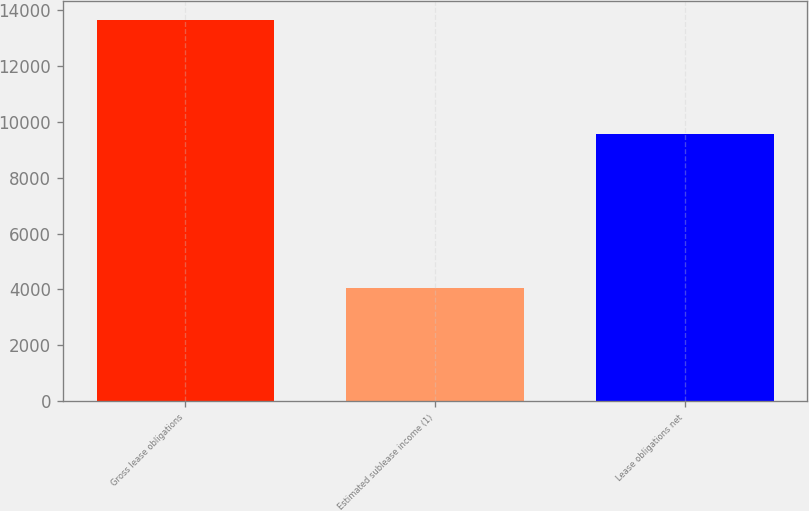Convert chart. <chart><loc_0><loc_0><loc_500><loc_500><bar_chart><fcel>Gross lease obligations<fcel>Estimated sublease income (1)<fcel>Lease obligations net<nl><fcel>13628<fcel>4051<fcel>9577<nl></chart> 